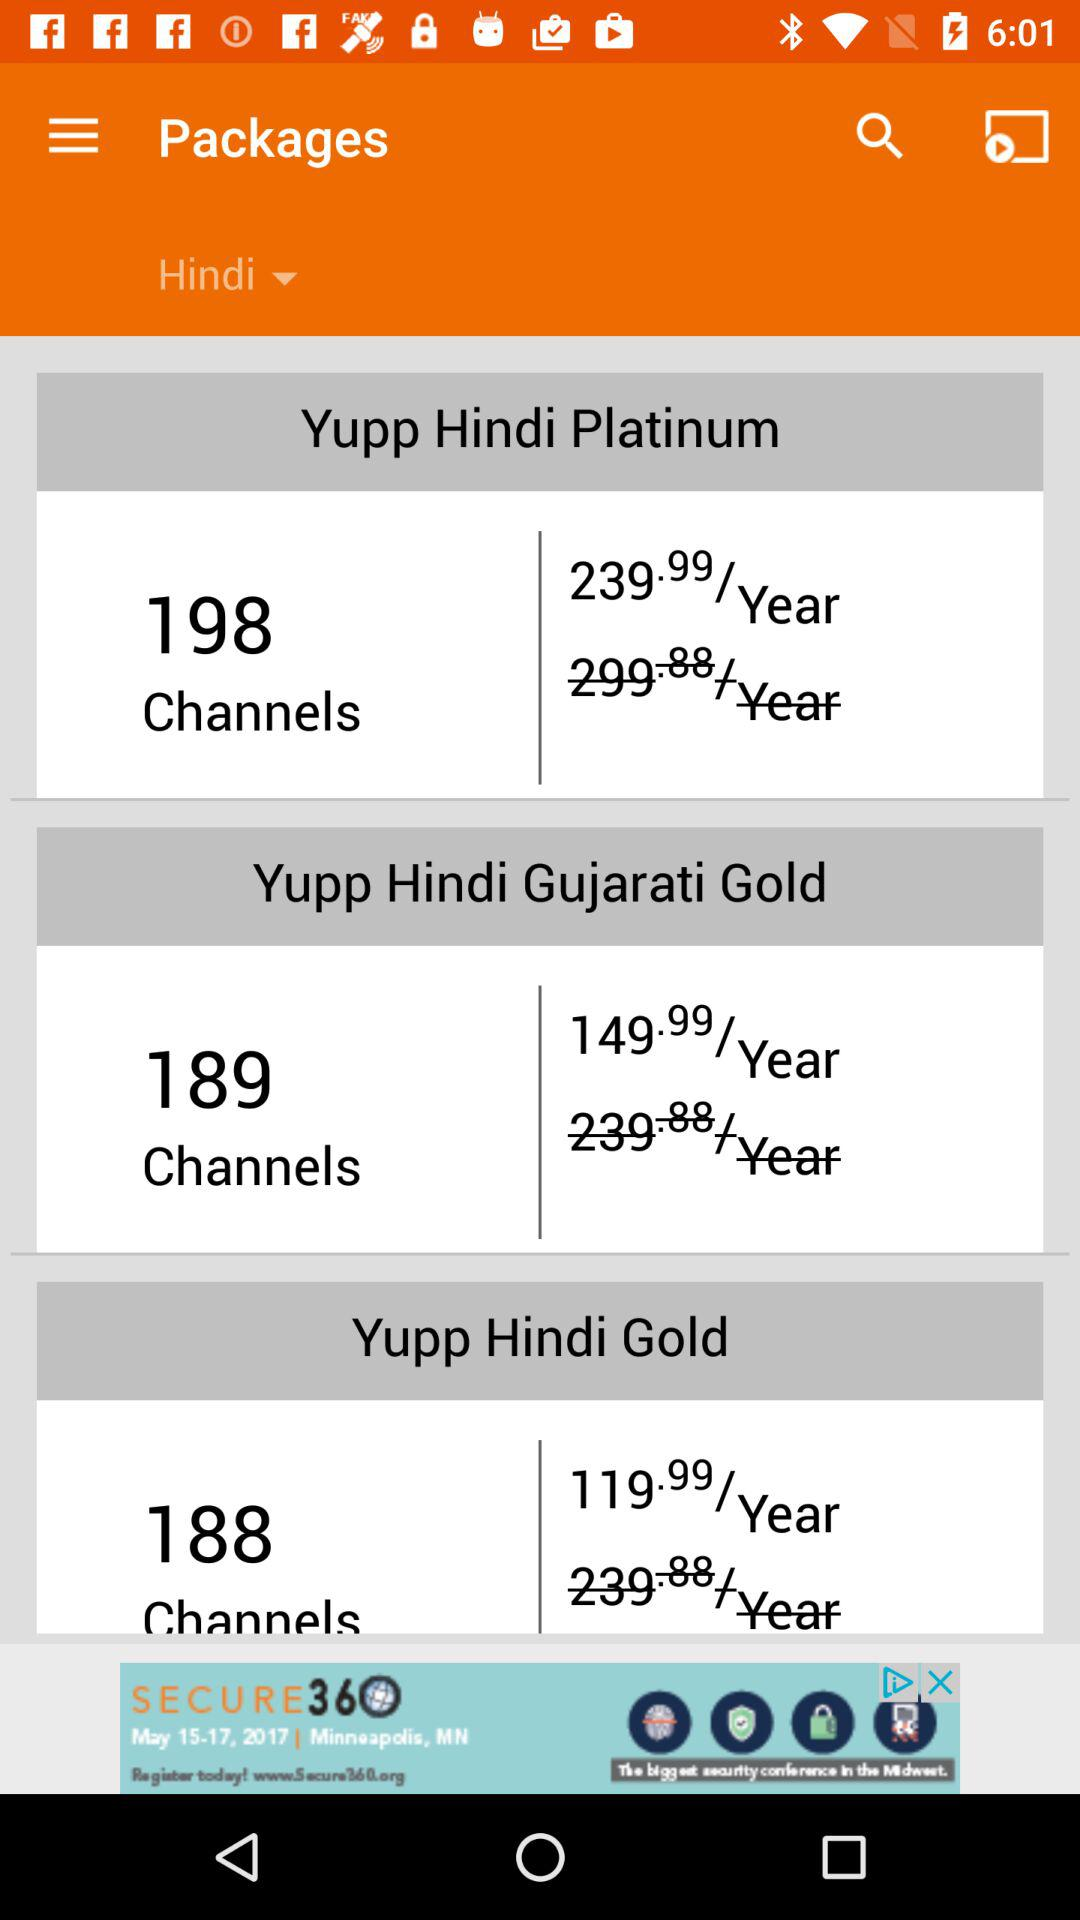How many packages are available for Hindi?
Answer the question using a single word or phrase. 3 